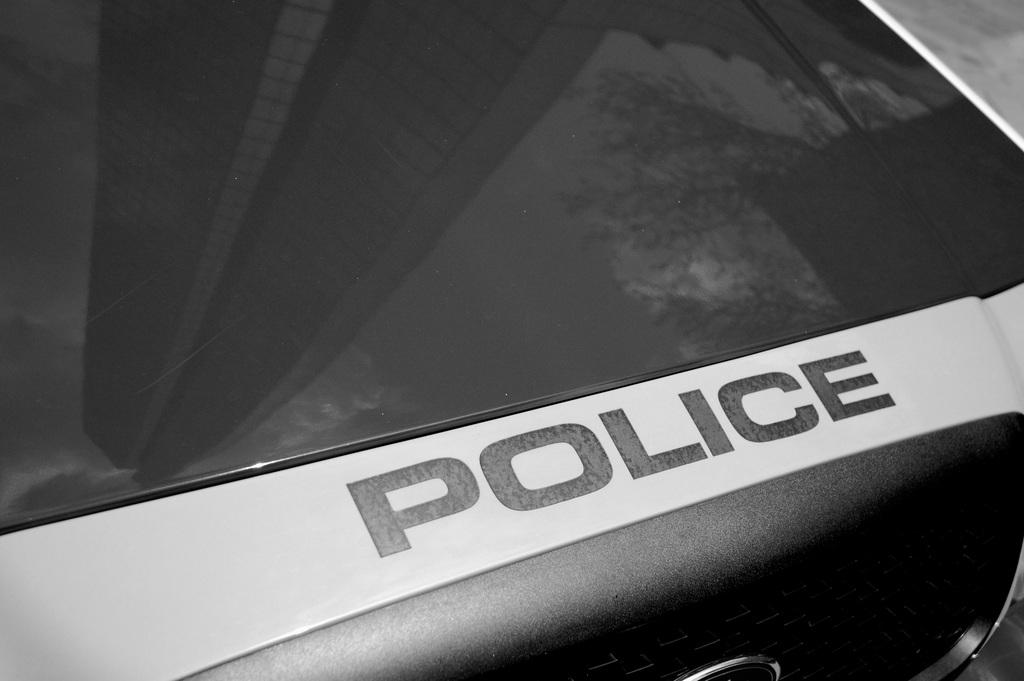What type of vehicle is present in the image? There is a vehicle with a board of police in the image. What can be seen reflected on the vehicle? There is a reflection of a building and a tree on the vehicle. How many times does the vehicle sneeze in the image? Vehicles do not sneeze, so this question is not applicable to the image. What type of attraction is present in the image? There is no attraction present in the image; it features a vehicle with a board of police and reflections of a building and a tree. 